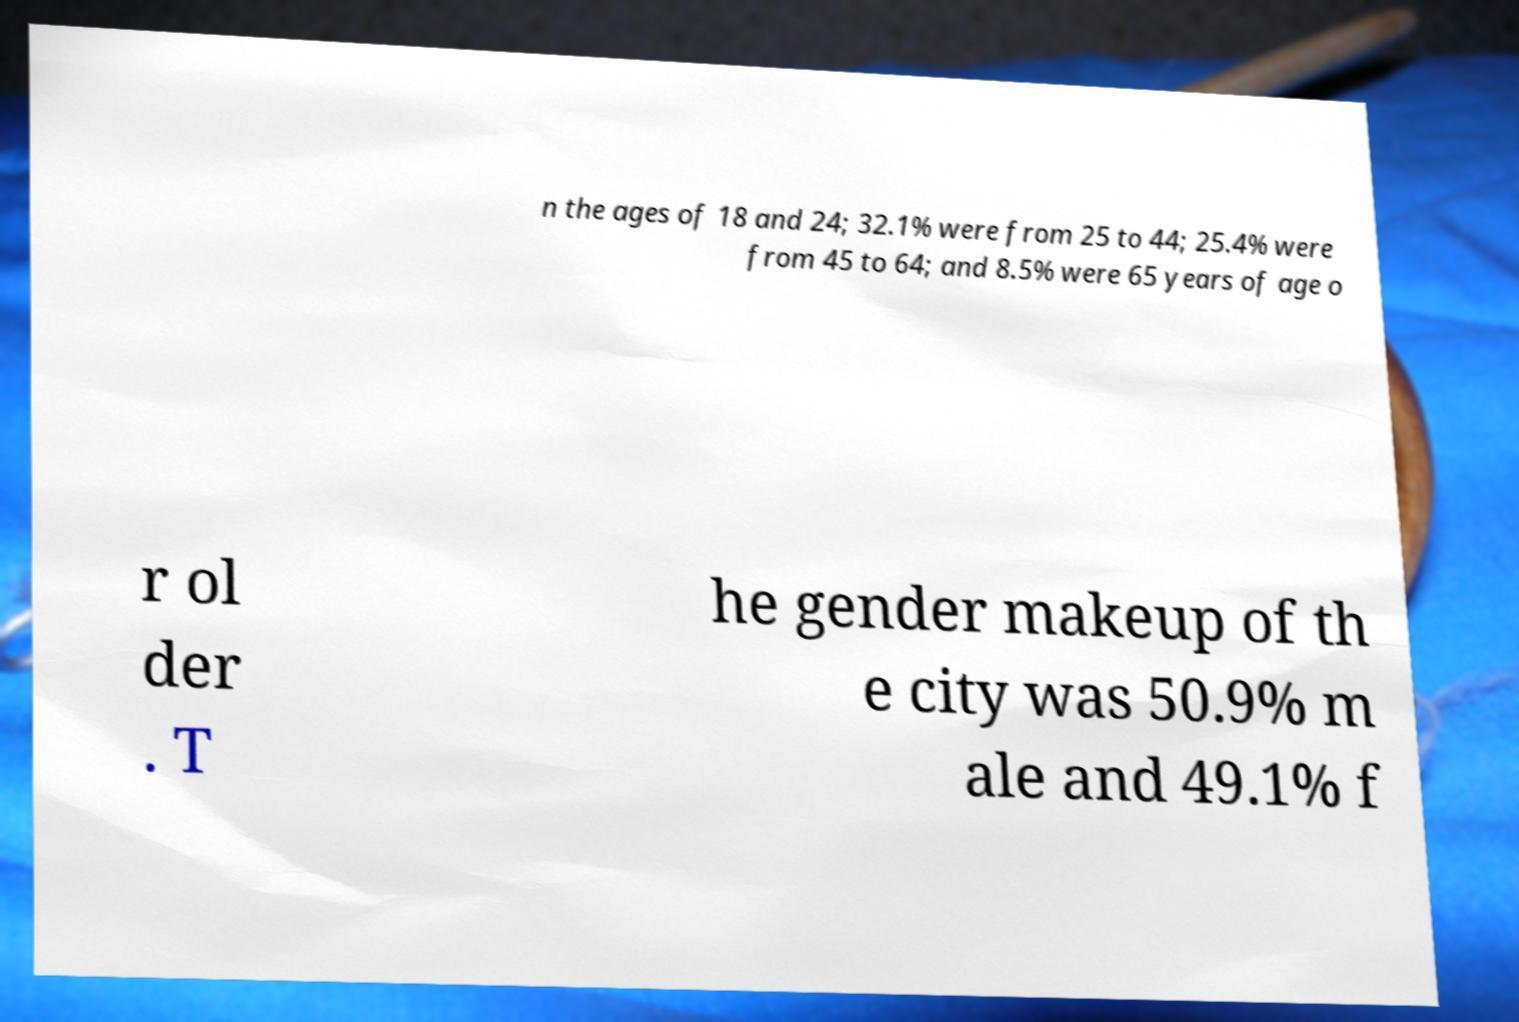Could you assist in decoding the text presented in this image and type it out clearly? n the ages of 18 and 24; 32.1% were from 25 to 44; 25.4% were from 45 to 64; and 8.5% were 65 years of age o r ol der . T he gender makeup of th e city was 50.9% m ale and 49.1% f 